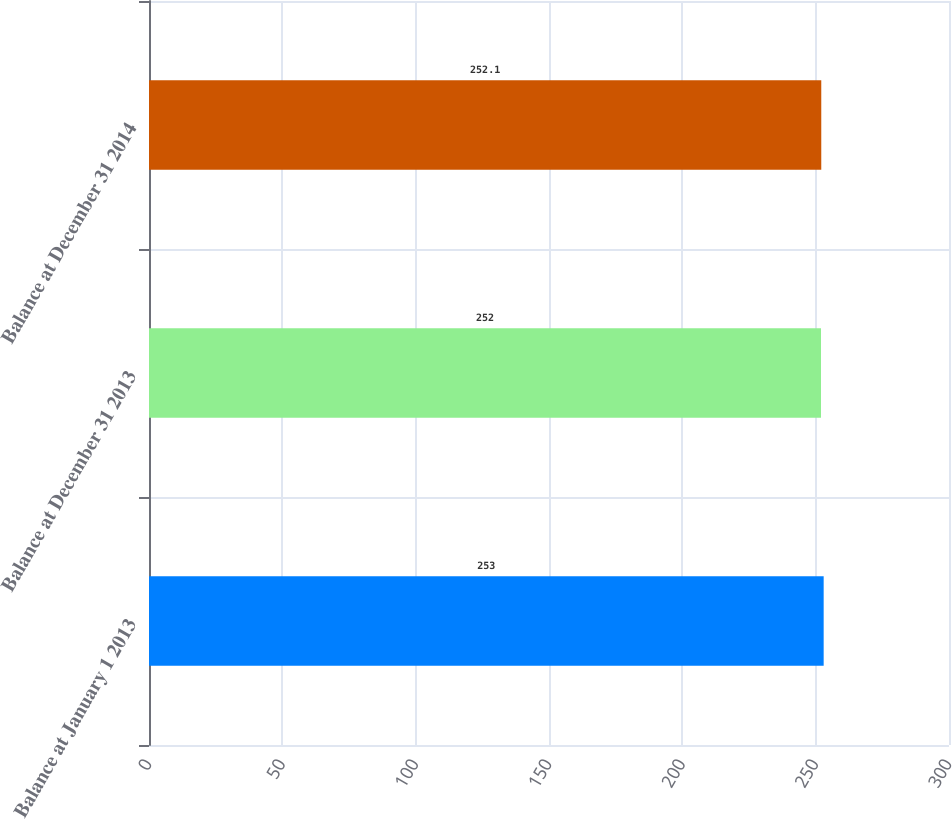<chart> <loc_0><loc_0><loc_500><loc_500><bar_chart><fcel>Balance at January 1 2013<fcel>Balance at December 31 2013<fcel>Balance at December 31 2014<nl><fcel>253<fcel>252<fcel>252.1<nl></chart> 